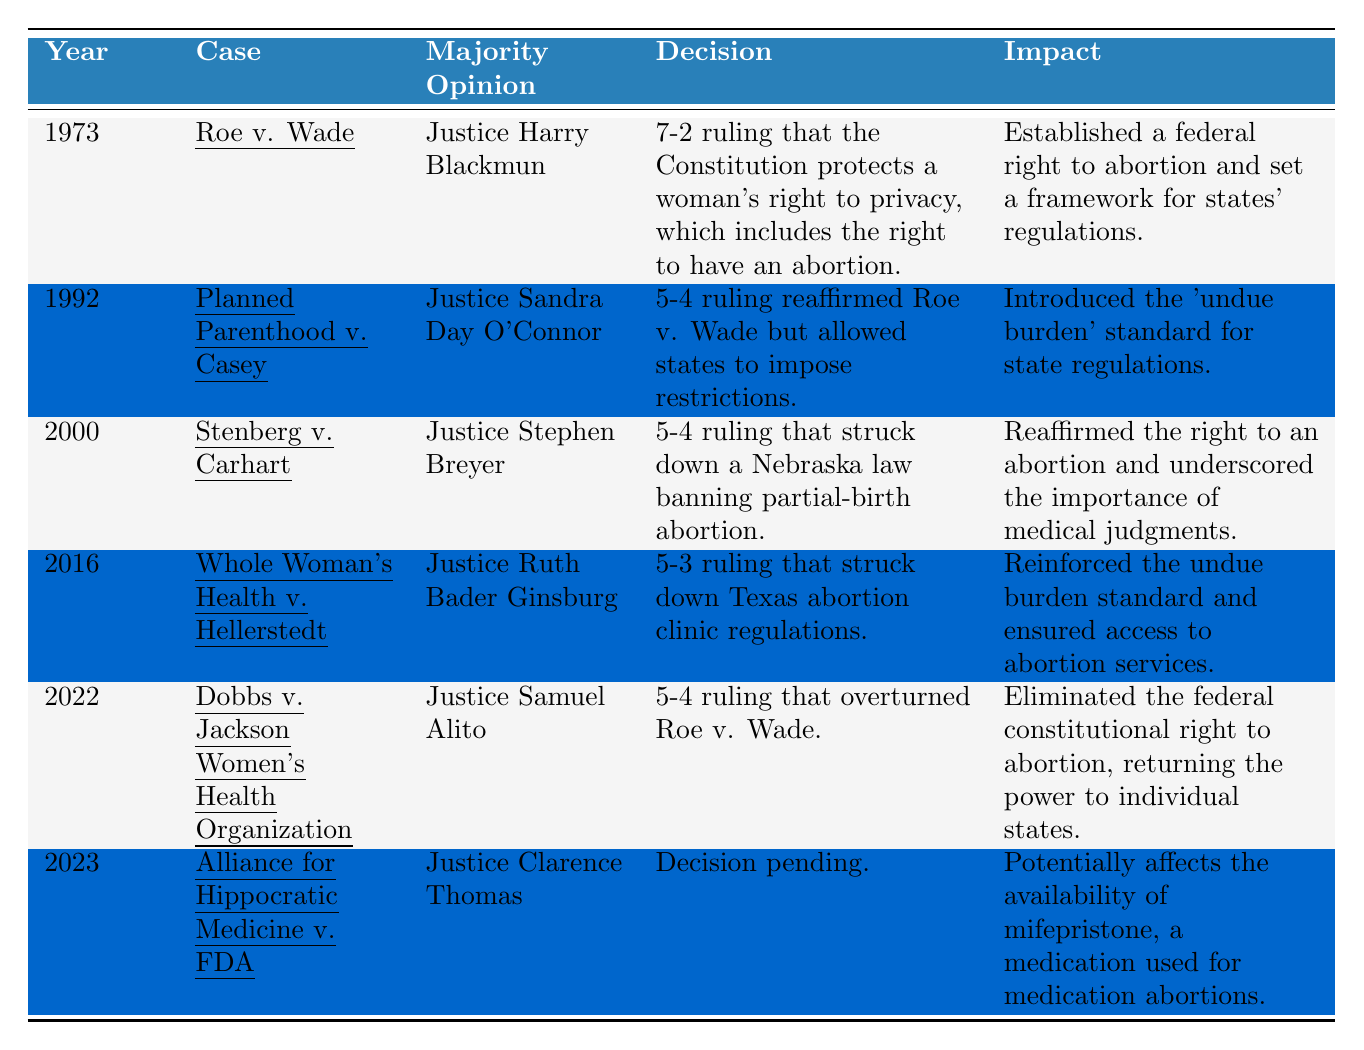What was the ruling in Roe v. Wade? The table states that Roe v. Wade had a 7-2 ruling which protects a woman's right to privacy including the right to an abortion.
Answer: 7-2 ruling protecting abortion rights What year was the Planned Parenthood v. Casey case decided? The table lists the year for Planned Parenthood v. Casey as 1992.
Answer: 1992 Which Justice wrote the majority opinion in Whole Woman's Health v. Hellerstedt? According to the table, Justice Ruth Bader Ginsburg wrote the majority opinion in this case.
Answer: Justice Ruth Bader Ginsburg What impact did the Dobbs v. Jackson Women's Health Organization ruling have? The table indicates that this ruling eliminated the federal constitutional right to abortion, returning power to individual states.
Answer: Eliminated federal abortion rights Is the decision for Alliance for Hippocratic Medicine v. FDA pending? The table shows that the decision is indeed pending for this case.
Answer: Yes How many rulings affirmed or reaffirmed the rights established in Roe v. Wade? Referring to the table, Roe v. Wade is reaffirmed in Planned Parenthood v. Casey and partially in Stenberg v. Carhart. Thus, there are two cases that affirmed Roe v. Wade.
Answer: 2 What is the average vote margin of the Supreme Court rulings on abortion rights presented in the table? The rulings are 7-2, 5-4, 5-4, 5-3, 5-4. The total vote margins are 5, 1, 1, 2, and 1. Averaging these (5 + 1 + 1 + 2 + 1 = 10, divided by 5 cases) results in an average margin of 2.
Answer: 2 Which case was decided most recently, and what was its impact? The table reveals that Alliance for Hippocratic Medicine v. FDA is the most recent case from 2023, potentially affecting the availability of mifepristone.
Answer: Alliance for Hippocratic Medicine v. FDA; impacts mifepristone availability How did the Supreme Court decisions on abortion rights evolve from 1973 to 2022? Analyzing the table, we see significant turning points: Roe v. Wade established a federal right, Casey allowed state restrictions, Stenberg reaffirmed abortion rights, Whole Woman's Health reinforced access, and then Dobbs overturned federal rights, returning power to states.
Answer: Evolved from federal rights to state control 